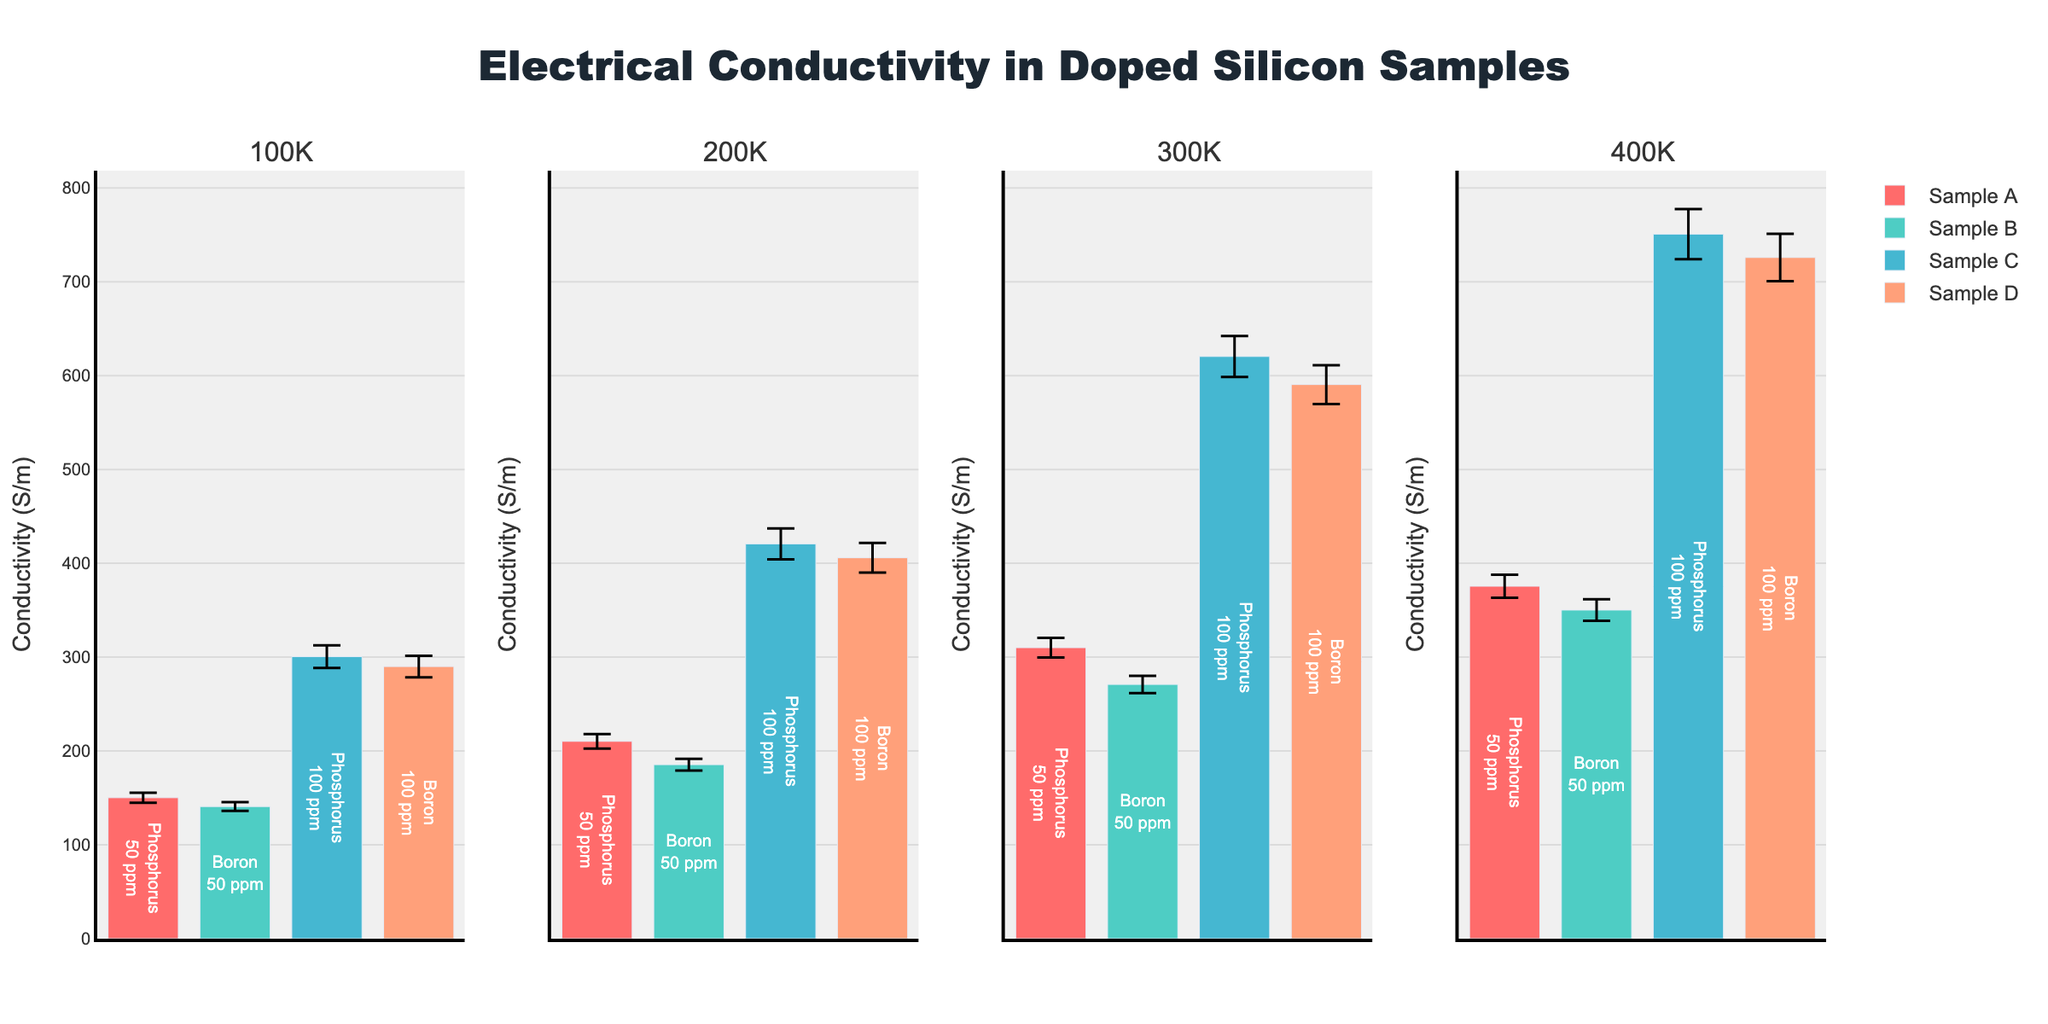What's the title of the figure? The title is usually at the top of the figure, and in this case, it’s prominently displayed.
Answer: Electrical Conductivity in Doped Silicon Samples What's the conductivity of Sample B at 200K and how is it visually represented? To find this, locate the subplot for 200K and identify Sample B. Note values for conductivity and error bars.
Answer: 185.4 S/m, represented by a turquoise bar with an error bar Which sample and doping element have the highest conductivity at 300K? Check the subplot for 300K, compare the heights of bars and their texts for doping elements.
Answer: Sample C, Phosphorus How does the conductivity of Sample A at 100K compare to Sample B at the same temperature? Locate both samples in the 100K subplot, compare the bar heights for conductivity values.
Answer: Sample A has higher conductivity than Sample B What is the range of error for Sample D at 400K? Locate Sample D in the 400K subplot, look at the size of the error bar and add/subtract from the mean value.
Answer: Approx. ±25.3 S/m Which temperature shows the largest difference between conductivities of Sample A and Sample C? Compute differences visually for each temperature subplot by comparing Sample A and Sample C bars.
Answer: 400K What is the doping concentration of Sample C? Look at the text inside the bars for Sample C in any subplot, as it displays doping concentration.
Answer: 100 ppm What is the trend in conductivity for Sample A from 100K to 400K? Observe Sample A's bar heights across subplots from 100K to 400K to identify the trend.
Answer: Increasing trend Is the error in conductivity measurement for Sample D consistently larger than Sample B across all temperatures? Compare the size of error bars for Sample B and Sample D across all subplots.
Answer: Yes How does the conductivity of Sample C at 100K compare to Sample D at 200K? Locate these samples in their respective subplots and compare the heights of their bars.
Answer: Sample C at 100K has higher conductivity than Sample D at 200K 